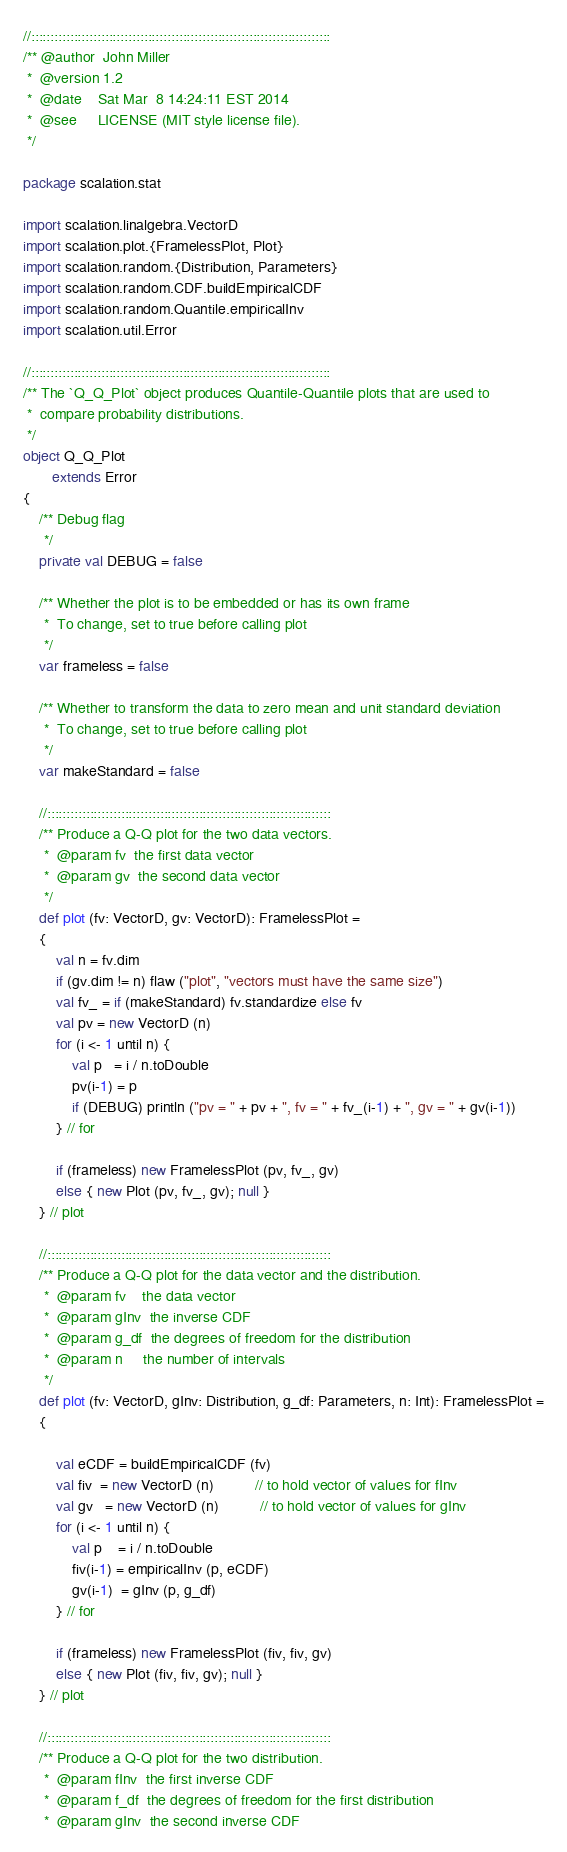<code> <loc_0><loc_0><loc_500><loc_500><_Scala_>
//:::::::::::::::::::::::::::::::::::::::::::::::::::::::::::::::::::::::::::::
/** @author  John Miller
 *  @version 1.2
 *  @date    Sat Mar  8 14:24:11 EST 2014
 *  @see     LICENSE (MIT style license file).
 */

package scalation.stat

import scalation.linalgebra.VectorD
import scalation.plot.{FramelessPlot, Plot}
import scalation.random.{Distribution, Parameters}
import scalation.random.CDF.buildEmpiricalCDF
import scalation.random.Quantile.empiricalInv
import scalation.util.Error

//:::::::::::::::::::::::::::::::::::::::::::::::::::::::::::::::::::::::::::::
/** The `Q_Q_Plot` object produces Quantile-Quantile plots that are used to
 *  compare probability distributions.
 */
object Q_Q_Plot
       extends Error
{
    /** Debug flag
     */
    private val DEBUG = false

    /** Whether the plot is to be embedded or has its own frame
     *  To change, set to true before calling plot
     */
    var frameless = false

    /** Whether to transform the data to zero mean and unit standard deviation
     *  To change, set to true before calling plot
     */
    var makeStandard = false             

    //:::::::::::::::::::::::::::::::::::::::::::::::::::::::::::::::::::::::::
    /** Produce a Q-Q plot for the two data vectors.
     *  @param fv  the first data vector
     *  @param gv  the second data vector
     */
    def plot (fv: VectorD, gv: VectorD): FramelessPlot =
    {
        val n = fv.dim
        if (gv.dim != n) flaw ("plot", "vectors must have the same size")
        val fv_ = if (makeStandard) fv.standardize else fv
        val pv = new VectorD (n)
        for (i <- 1 until n) {
            val p   = i / n.toDouble
            pv(i-1) = p
            if (DEBUG) println ("pv = " + pv + ", fv = " + fv_(i-1) + ", gv = " + gv(i-1))
        } // for

        if (frameless) new FramelessPlot (pv, fv_, gv)
        else { new Plot (pv, fv_, gv); null }
    } // plot

    //:::::::::::::::::::::::::::::::::::::::::::::::::::::::::::::::::::::::::
    /** Produce a Q-Q plot for the data vector and the distribution.
     *  @param fv    the data vector
     *  @param gInv  the inverse CDF
     *  @param g_df  the degrees of freedom for the distribution
     *  @param n     the number of intervals
     */
    def plot (fv: VectorD, gInv: Distribution, g_df: Parameters, n: Int): FramelessPlot =
    {

        val eCDF = buildEmpiricalCDF (fv)
        val fiv  = new VectorD (n)          // to hold vector of values for fInv
        val gv   = new VectorD (n)          // to hold vector of values for gInv
        for (i <- 1 until n) {
            val p    = i / n.toDouble
            fiv(i-1) = empiricalInv (p, eCDF)
            gv(i-1)  = gInv (p, g_df)
        } // for

        if (frameless) new FramelessPlot (fiv, fiv, gv)
        else { new Plot (fiv, fiv, gv); null }
    } // plot

    //:::::::::::::::::::::::::::::::::::::::::::::::::::::::::::::::::::::::::
    /** Produce a Q-Q plot for the two distribution.
     *  @param fInv  the first inverse CDF
     *  @param f_df  the degrees of freedom for the first distribution
     *  @param gInv  the second inverse CDF</code> 